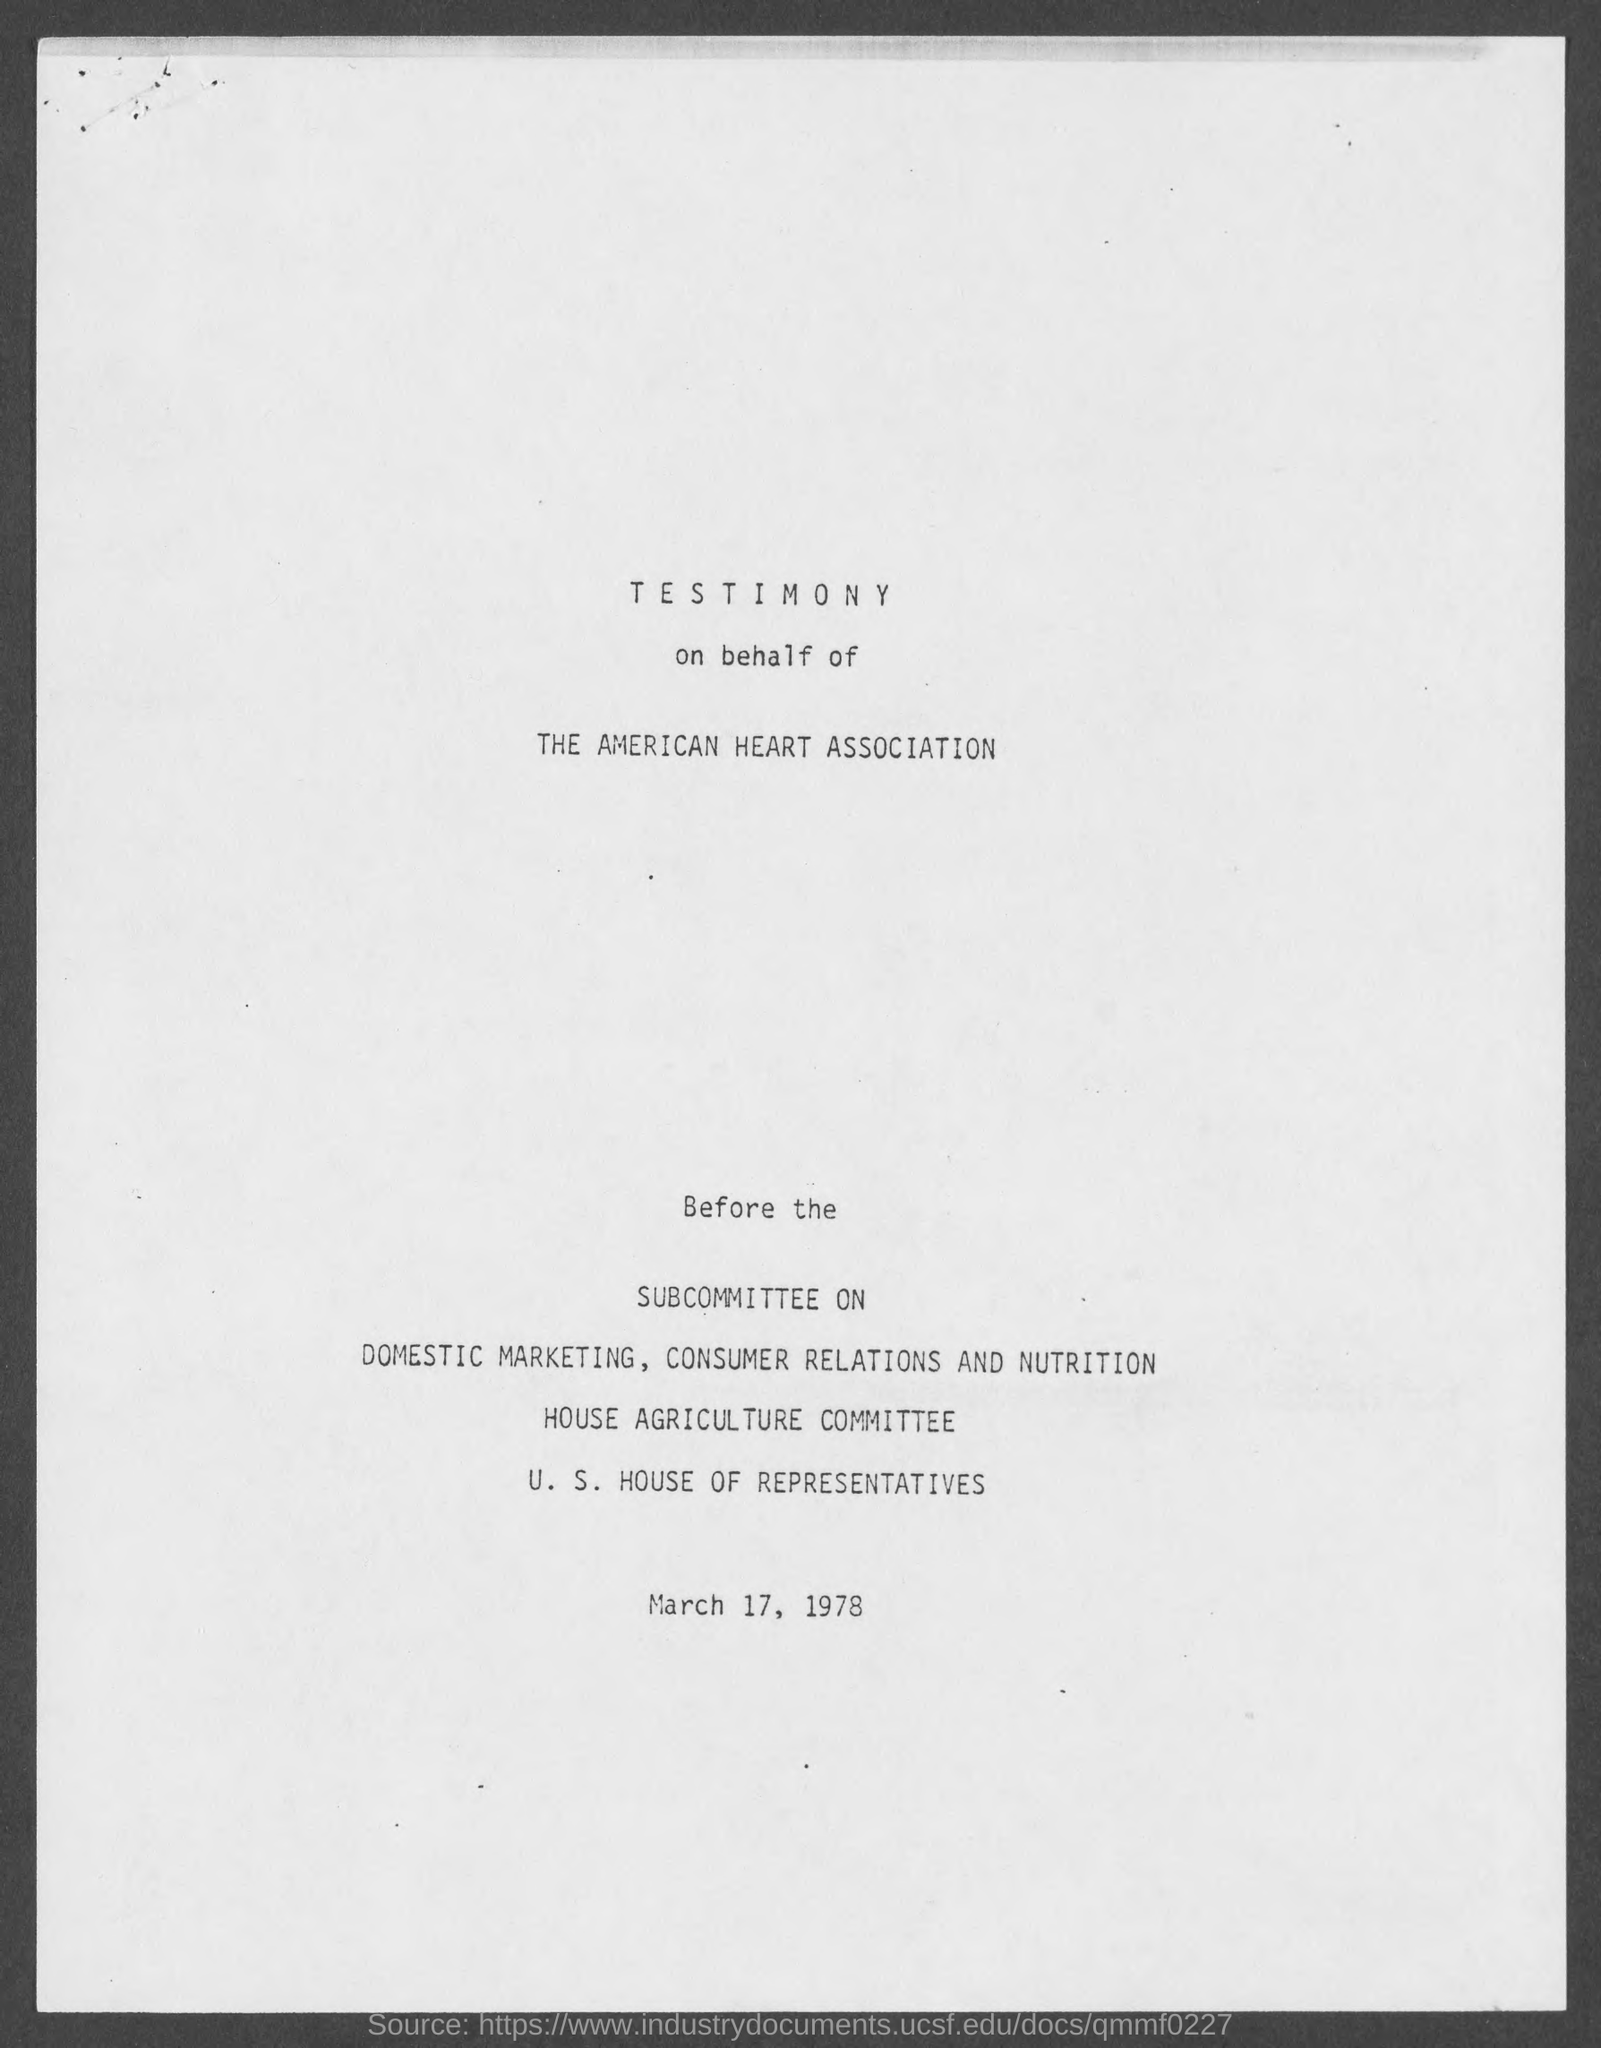Highlight a few significant elements in this photo. The testimony is given on behalf of the American Heart Association. 